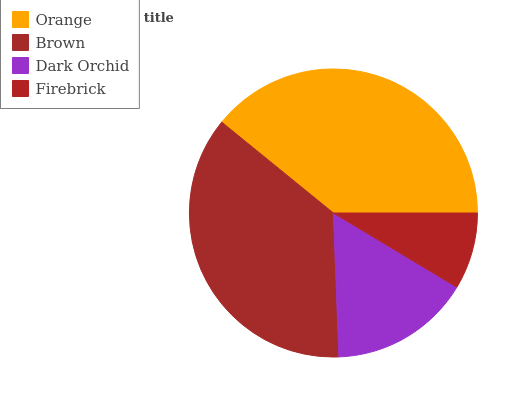Is Firebrick the minimum?
Answer yes or no. Yes. Is Orange the maximum?
Answer yes or no. Yes. Is Brown the minimum?
Answer yes or no. No. Is Brown the maximum?
Answer yes or no. No. Is Orange greater than Brown?
Answer yes or no. Yes. Is Brown less than Orange?
Answer yes or no. Yes. Is Brown greater than Orange?
Answer yes or no. No. Is Orange less than Brown?
Answer yes or no. No. Is Brown the high median?
Answer yes or no. Yes. Is Dark Orchid the low median?
Answer yes or no. Yes. Is Firebrick the high median?
Answer yes or no. No. Is Brown the low median?
Answer yes or no. No. 